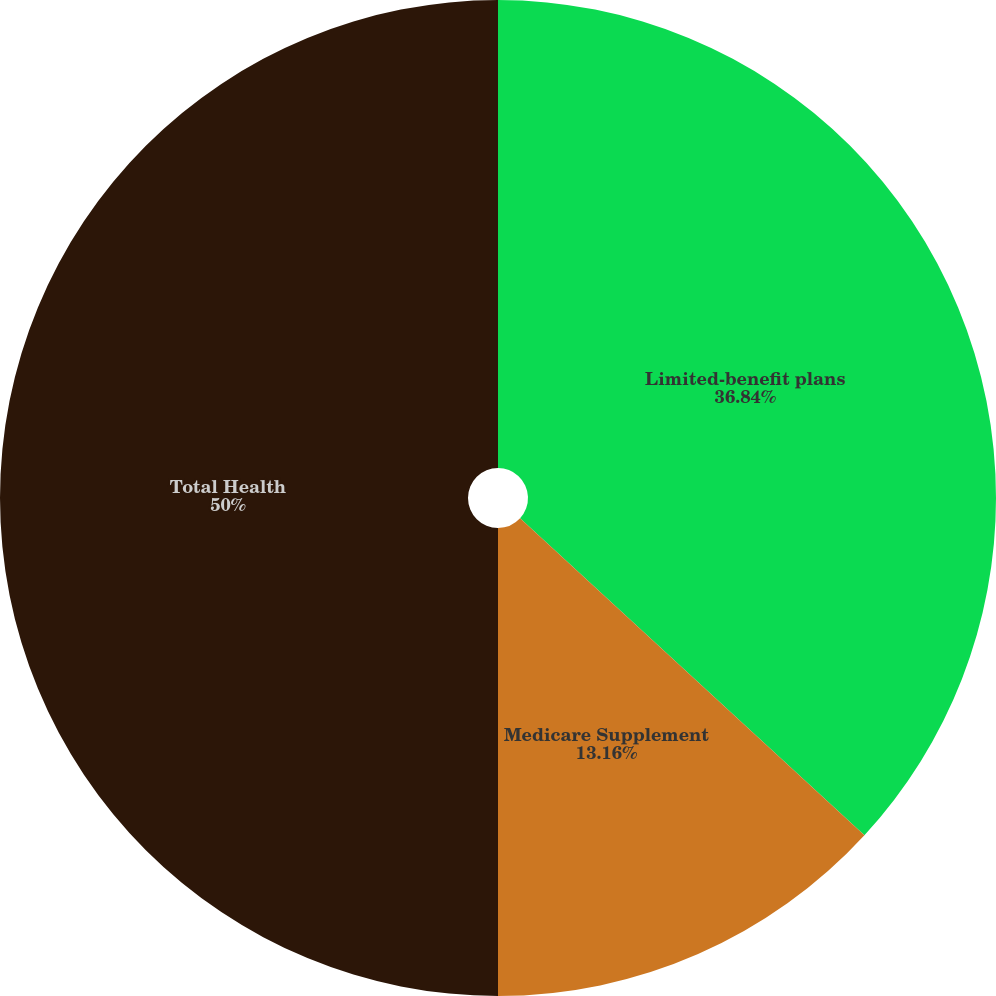Convert chart to OTSL. <chart><loc_0><loc_0><loc_500><loc_500><pie_chart><fcel>Limited-benefit plans<fcel>Medicare Supplement<fcel>Medicare Part D<fcel>Total Health<nl><fcel>36.84%<fcel>13.16%<fcel>0.0%<fcel>50.0%<nl></chart> 